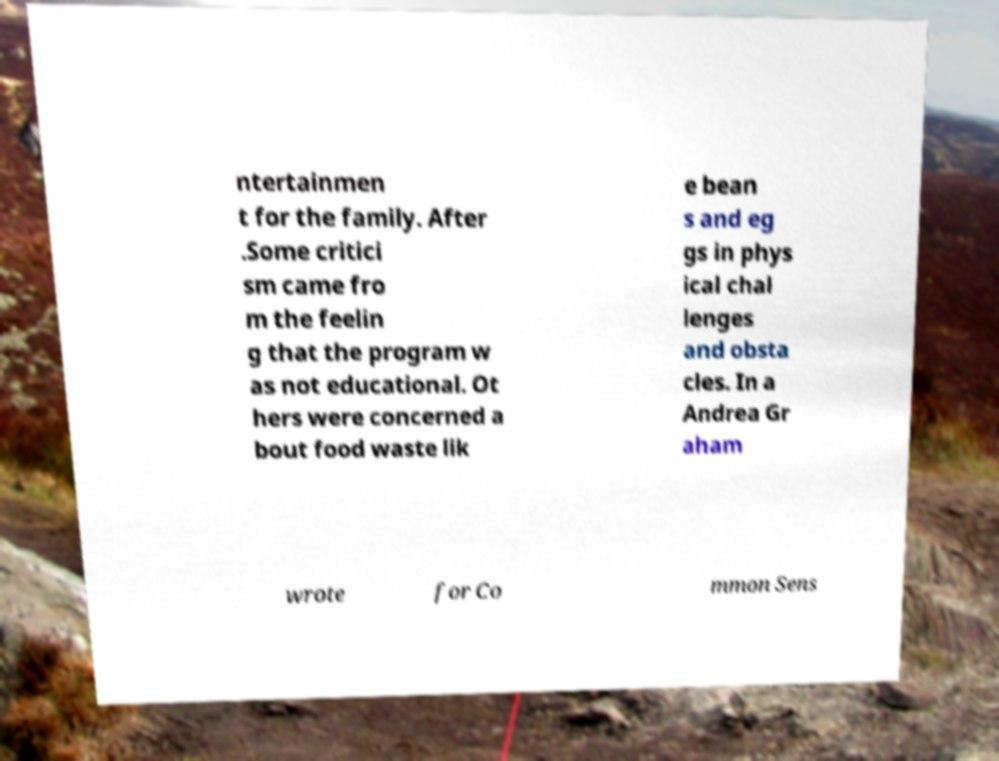Could you assist in decoding the text presented in this image and type it out clearly? ntertainmen t for the family. After .Some critici sm came fro m the feelin g that the program w as not educational. Ot hers were concerned a bout food waste lik e bean s and eg gs in phys ical chal lenges and obsta cles. In a Andrea Gr aham wrote for Co mmon Sens 